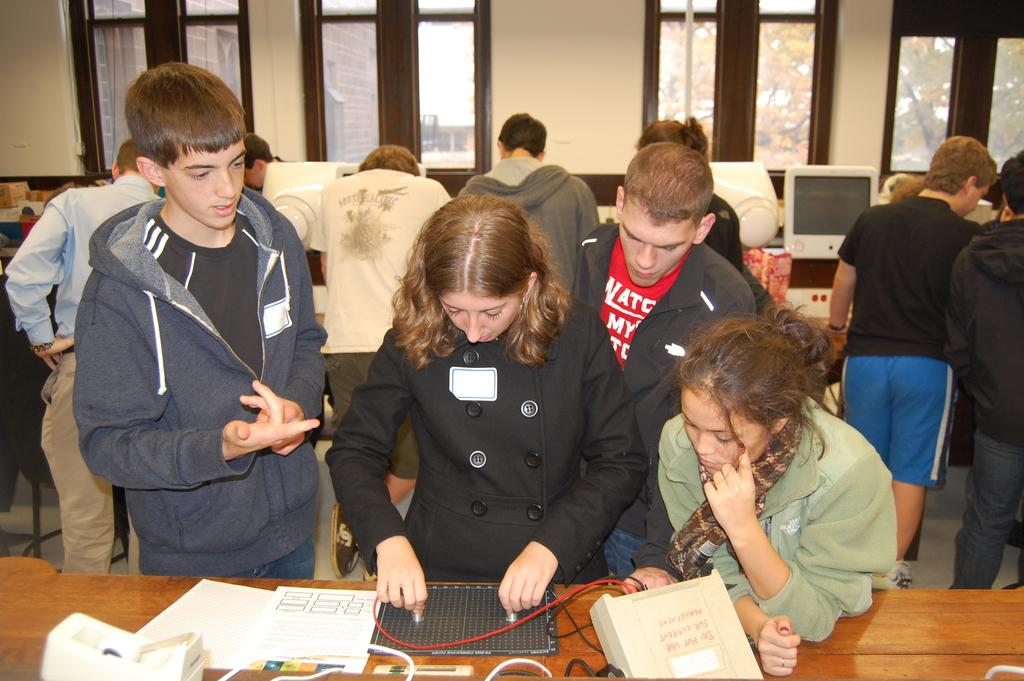Who or what can be seen in the image? There are people in the image. What architectural features are present in the image? There are windows in the image. What electronic devices are visible in the image? There is a tablet and a monitor in the image. What can be found in the image besides people and electronic devices? There are objects in the image. What can be seen through the windows in the image? Through the windows, a building and trees are visible. What type of powder is being used by the people in the image? There is no powder visible or mentioned in the image. 